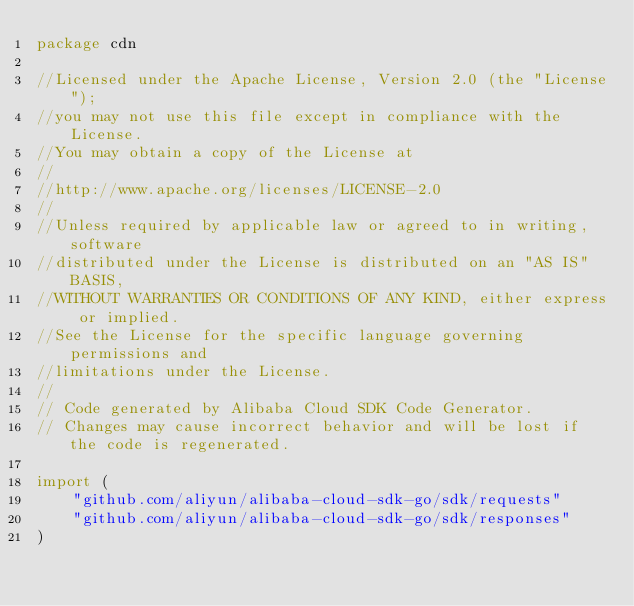Convert code to text. <code><loc_0><loc_0><loc_500><loc_500><_Go_>package cdn

//Licensed under the Apache License, Version 2.0 (the "License");
//you may not use this file except in compliance with the License.
//You may obtain a copy of the License at
//
//http://www.apache.org/licenses/LICENSE-2.0
//
//Unless required by applicable law or agreed to in writing, software
//distributed under the License is distributed on an "AS IS" BASIS,
//WITHOUT WARRANTIES OR CONDITIONS OF ANY KIND, either express or implied.
//See the License for the specific language governing permissions and
//limitations under the License.
//
// Code generated by Alibaba Cloud SDK Code Generator.
// Changes may cause incorrect behavior and will be lost if the code is regenerated.

import (
	"github.com/aliyun/alibaba-cloud-sdk-go/sdk/requests"
	"github.com/aliyun/alibaba-cloud-sdk-go/sdk/responses"
)
</code> 